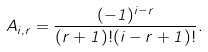Convert formula to latex. <formula><loc_0><loc_0><loc_500><loc_500>A _ { i , r } = \frac { ( - 1 ) ^ { i - r } } { ( r + 1 ) ! ( i - r + 1 ) ! } .</formula> 